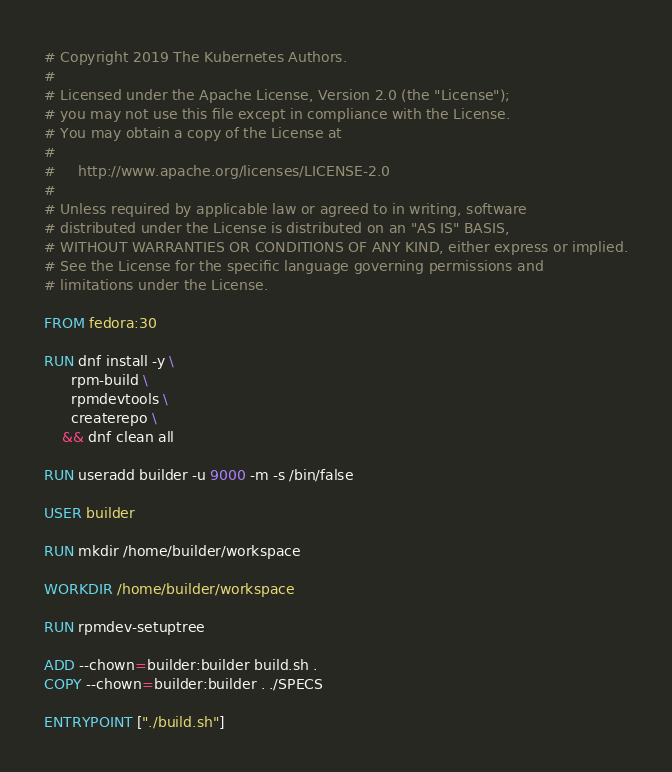<code> <loc_0><loc_0><loc_500><loc_500><_Dockerfile_># Copyright 2019 The Kubernetes Authors.
#
# Licensed under the Apache License, Version 2.0 (the "License");
# you may not use this file except in compliance with the License.
# You may obtain a copy of the License at
#
#     http://www.apache.org/licenses/LICENSE-2.0
#
# Unless required by applicable law or agreed to in writing, software
# distributed under the License is distributed on an "AS IS" BASIS,
# WITHOUT WARRANTIES OR CONDITIONS OF ANY KIND, either express or implied.
# See the License for the specific language governing permissions and
# limitations under the License.

FROM fedora:30

RUN dnf install -y \
      rpm-build \
      rpmdevtools \
      createrepo \
    && dnf clean all

RUN useradd builder -u 9000 -m -s /bin/false

USER builder

RUN mkdir /home/builder/workspace

WORKDIR /home/builder/workspace

RUN rpmdev-setuptree

ADD --chown=builder:builder build.sh .
COPY --chown=builder:builder . ./SPECS

ENTRYPOINT ["./build.sh"]
</code> 